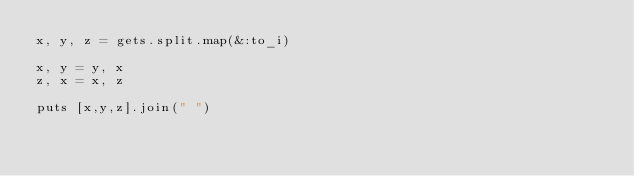Convert code to text. <code><loc_0><loc_0><loc_500><loc_500><_Ruby_>x, y, z = gets.split.map(&:to_i)

x, y = y, x
z, x = x, z

puts [x,y,z].join(" ")</code> 